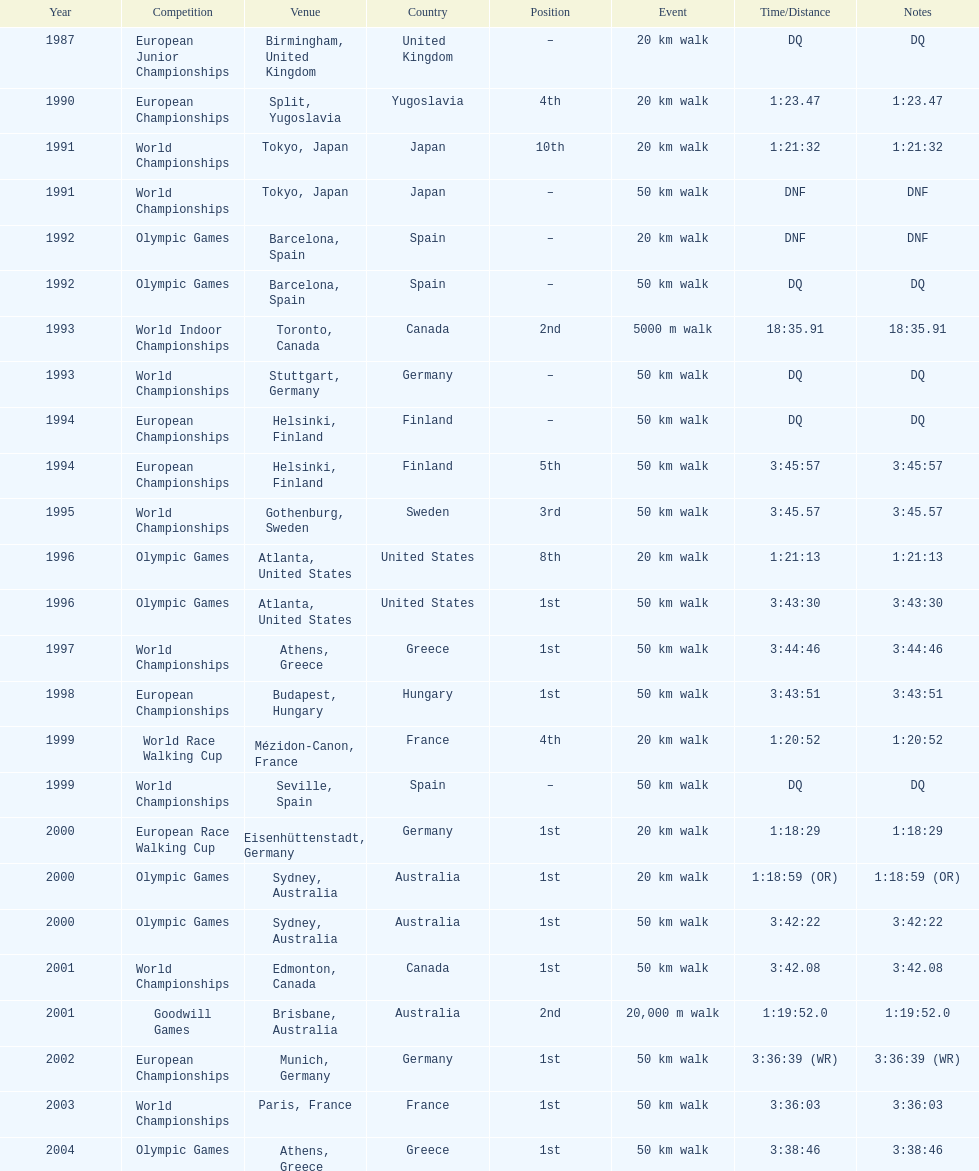How long did it take to walk 50 km in the 2004 olympic games? 3:38:46. 